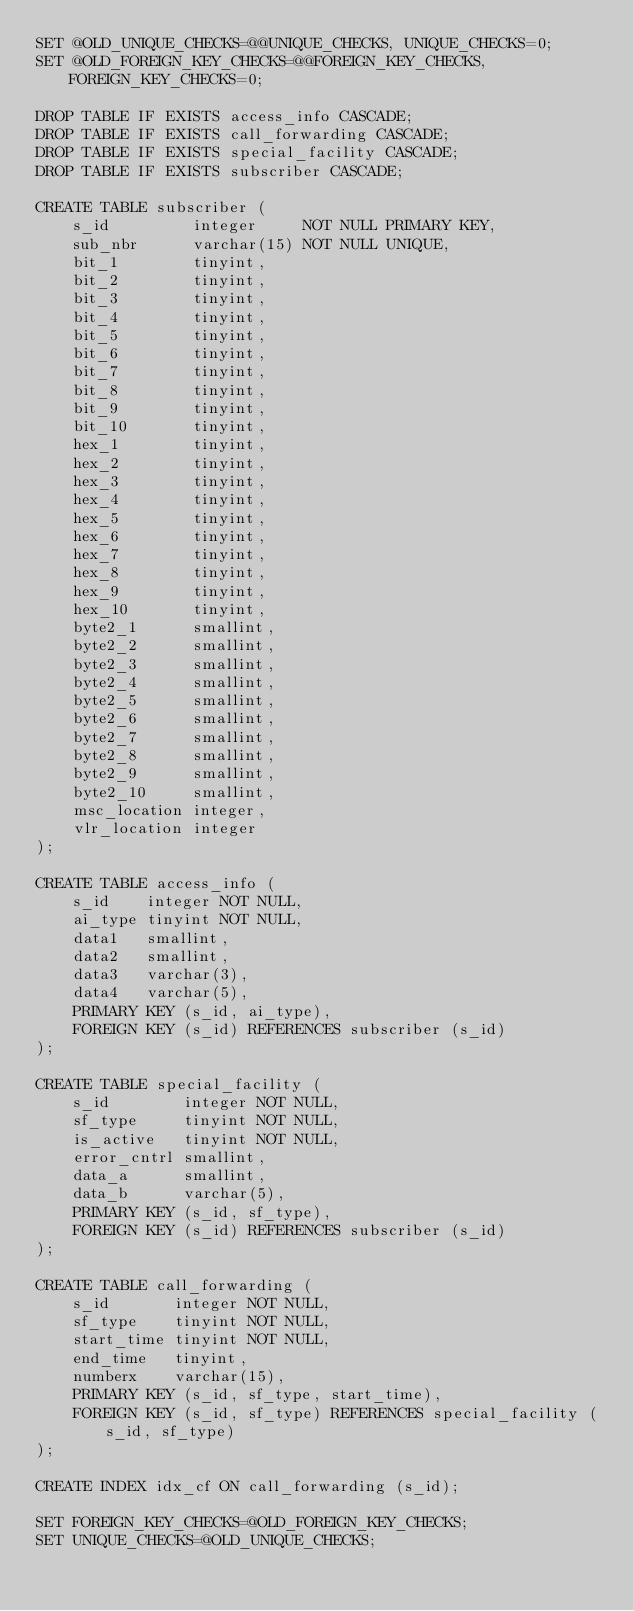<code> <loc_0><loc_0><loc_500><loc_500><_SQL_>SET @OLD_UNIQUE_CHECKS=@@UNIQUE_CHECKS, UNIQUE_CHECKS=0;
SET @OLD_FOREIGN_KEY_CHECKS=@@FOREIGN_KEY_CHECKS, FOREIGN_KEY_CHECKS=0;

DROP TABLE IF EXISTS access_info CASCADE;
DROP TABLE IF EXISTS call_forwarding CASCADE;
DROP TABLE IF EXISTS special_facility CASCADE;
DROP TABLE IF EXISTS subscriber CASCADE;

CREATE TABLE subscriber (
    s_id         integer     NOT NULL PRIMARY KEY,
    sub_nbr      varchar(15) NOT NULL UNIQUE,
    bit_1        tinyint,
    bit_2        tinyint,
    bit_3        tinyint,
    bit_4        tinyint,
    bit_5        tinyint,
    bit_6        tinyint,
    bit_7        tinyint,
    bit_8        tinyint,
    bit_9        tinyint,
    bit_10       tinyint,
    hex_1        tinyint,
    hex_2        tinyint,
    hex_3        tinyint,
    hex_4        tinyint,
    hex_5        tinyint,
    hex_6        tinyint,
    hex_7        tinyint,
    hex_8        tinyint,
    hex_9        tinyint,
    hex_10       tinyint,
    byte2_1      smallint,
    byte2_2      smallint,
    byte2_3      smallint,
    byte2_4      smallint,
    byte2_5      smallint,
    byte2_6      smallint,
    byte2_7      smallint,
    byte2_8      smallint,
    byte2_9      smallint,
    byte2_10     smallint,
    msc_location integer,
    vlr_location integer
);

CREATE TABLE access_info (
    s_id    integer NOT NULL,
    ai_type tinyint NOT NULL,
    data1   smallint,
    data2   smallint,
    data3   varchar(3),
    data4   varchar(5),
    PRIMARY KEY (s_id, ai_type),
    FOREIGN KEY (s_id) REFERENCES subscriber (s_id)
);

CREATE TABLE special_facility (
    s_id        integer NOT NULL,
    sf_type     tinyint NOT NULL,
    is_active   tinyint NOT NULL,
    error_cntrl smallint,
    data_a      smallint,
    data_b      varchar(5),
    PRIMARY KEY (s_id, sf_type),
    FOREIGN KEY (s_id) REFERENCES subscriber (s_id)
);

CREATE TABLE call_forwarding (
    s_id       integer NOT NULL,
    sf_type    tinyint NOT NULL,
    start_time tinyint NOT NULL,
    end_time   tinyint,
    numberx    varchar(15),
    PRIMARY KEY (s_id, sf_type, start_time),
    FOREIGN KEY (s_id, sf_type) REFERENCES special_facility (s_id, sf_type)
);

CREATE INDEX idx_cf ON call_forwarding (s_id);

SET FOREIGN_KEY_CHECKS=@OLD_FOREIGN_KEY_CHECKS;
SET UNIQUE_CHECKS=@OLD_UNIQUE_CHECKS;</code> 